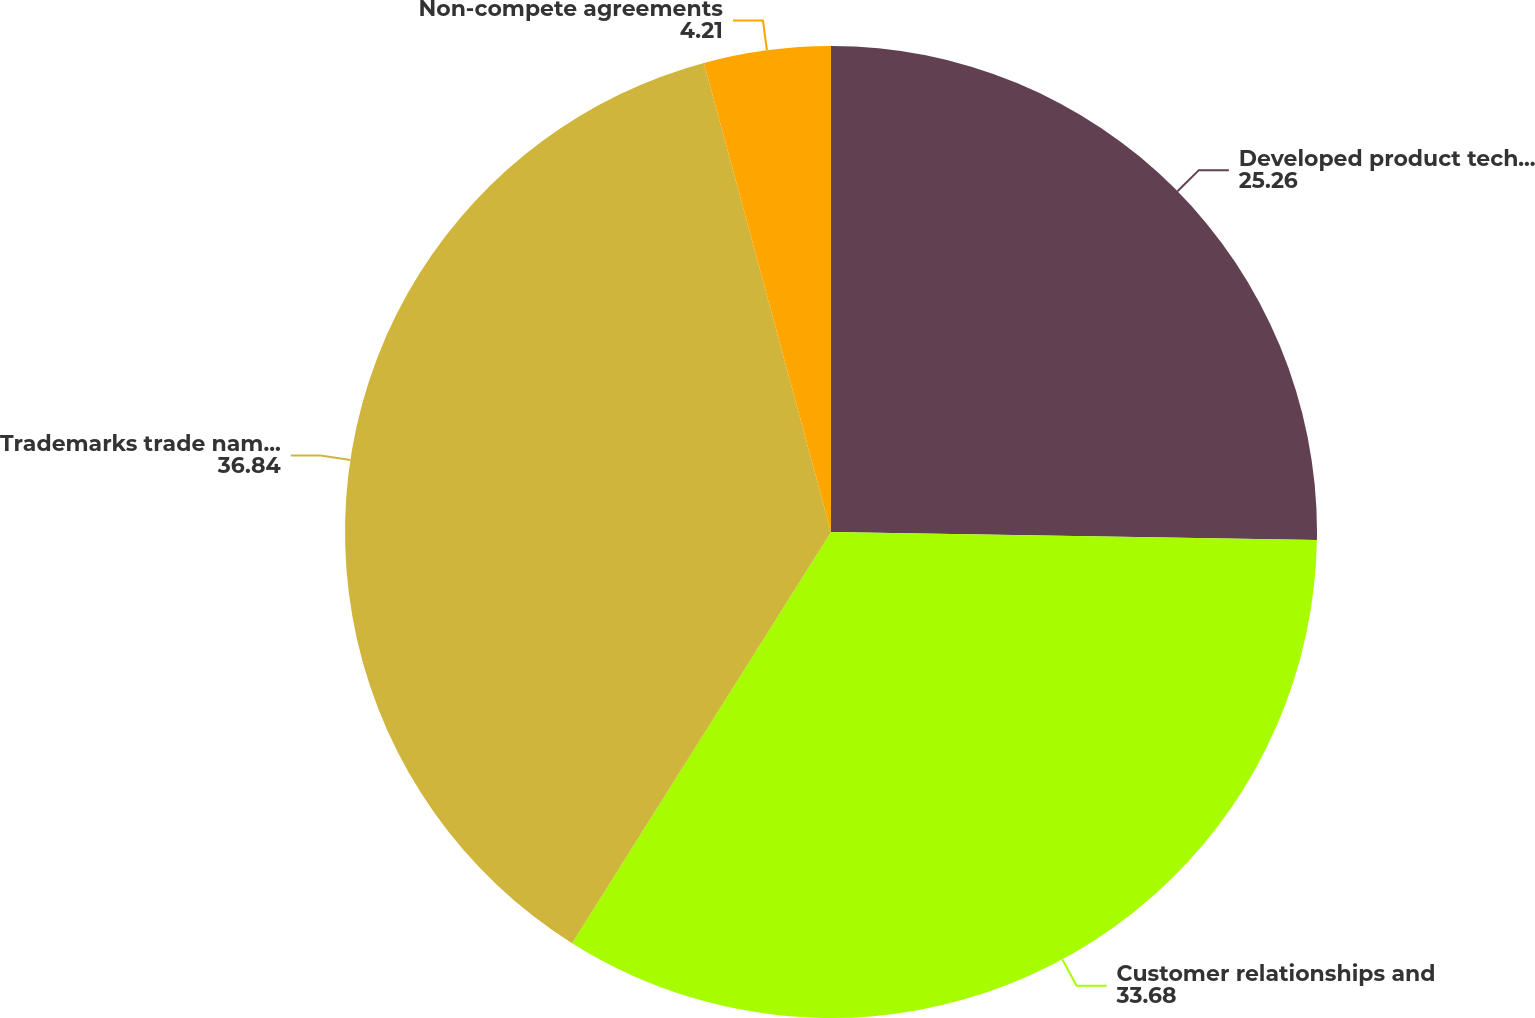Convert chart to OTSL. <chart><loc_0><loc_0><loc_500><loc_500><pie_chart><fcel>Developed product technology<fcel>Customer relationships and<fcel>Trademarks trade names and<fcel>Non-compete agreements<nl><fcel>25.26%<fcel>33.68%<fcel>36.84%<fcel>4.21%<nl></chart> 